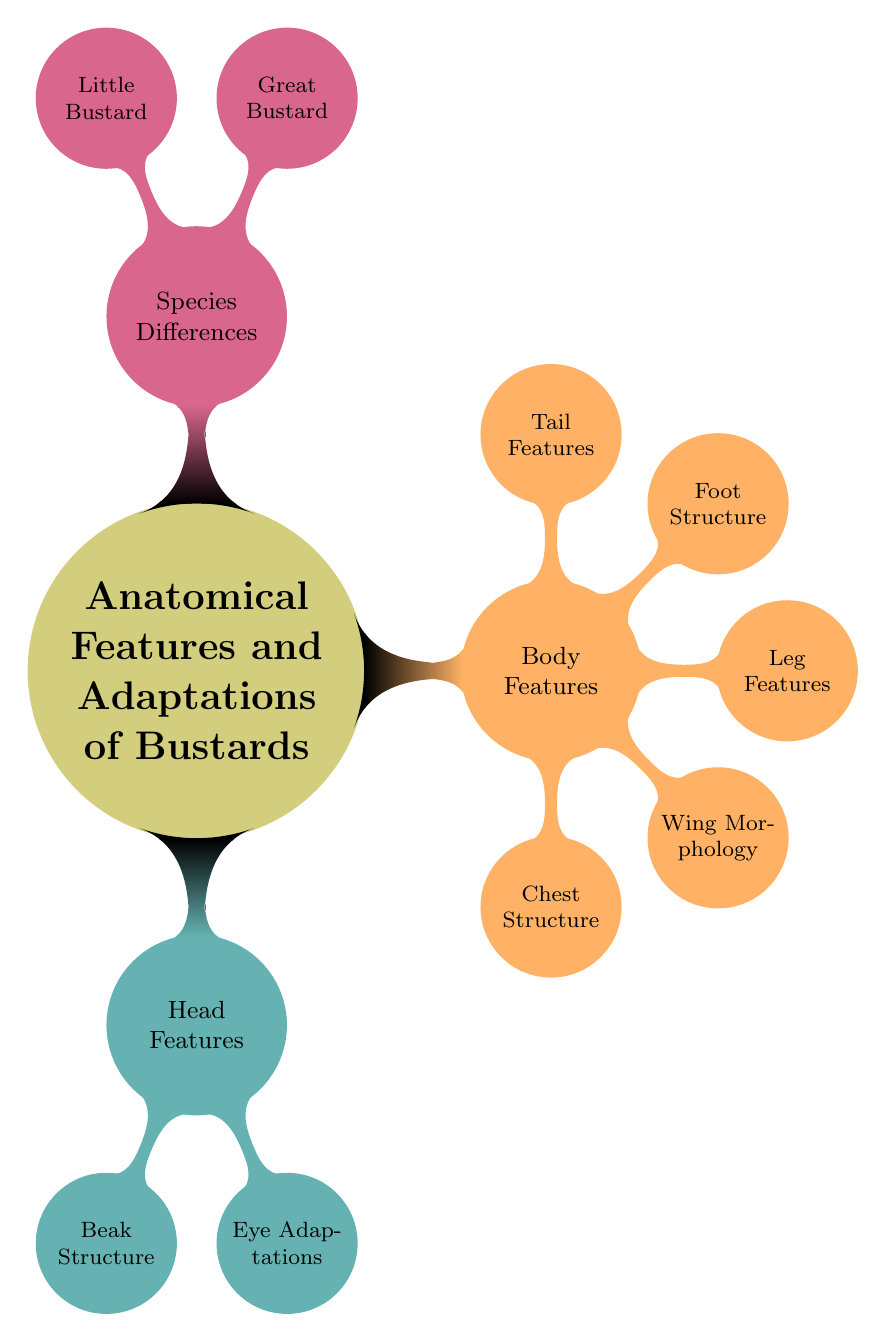What are the two main categories highlighted in the diagram? The diagram shows "Head Features" and "Body Features" as the primary categories under the main title. These categories are situated directly under the main topic, clearly labeling the distinct anatomical aspects of bustards.
Answer: Head Features, Body Features How many key features are listed under the Body Features category? Under the "Body Features" category, there are five specific features listed: "Chest Structure," "Wing Morphology," "Leg Features," "Foot Structure," and "Tail Features." This total is determined by counting each listed feature in the Body Features category.
Answer: Five Which adaptation is associated with both head and body structures according to the diagram? While the diagram does not specify a direct overlap between head and body adaptations, adaptations related to both structures can be inferred. However, "Eye Adaptations" are directly associated with the head, and "Wing Morphology" for the body can be linked when considering flight, but they remain separate categories in the diagram.
Answer: None specified What is the specific feature listed under the Head Features category? The only two features listed under the "Head Features" category are "Beak Structure" and "Eye Adaptations." These features detail aspects of a bustard's head and its adaptations. Since the question focuses on specific features, both are included in the concise answer.
Answer: Beak Structure, Eye Adaptations What are the names of the two bustard species mentioned? The diagram identifies "Great Bustard" and "Little Bustard" as the two species under the "Species Differences" category. These species are directly labeled under this category, making them easy to identify.
Answer: Great Bustard, Little Bustard How many features are listed under the Head Features category? The "Head Features" category consists of two distinct features: "Beak Structure" and "Eye Adaptations." This number is derived by counting the features shown in this section of the diagram.
Answer: Two Which feature might indicate behavioral adaptation in bustards? "Wing Morphology" can indicate behavioral adaptation in bustards, as wing shape and structure are crucial for flight patterns, which are integral to their behaviors such as mating displays or escaping predators. This is inferred from identifying the significance of wing structure in avian behavior.
Answer: Wing Morphology What is the conceptual relationship between "Leg Features" and "Foot Structure"? "Leg Features" and "Foot Structure" are both categorized under "Body Features," indicating they are both parts of the anatomical structure related to support and movement in bustards. This relationship is illustrated by their position under the same primary branch in the diagram.
Answer: Anatomical structure related to support and movement 